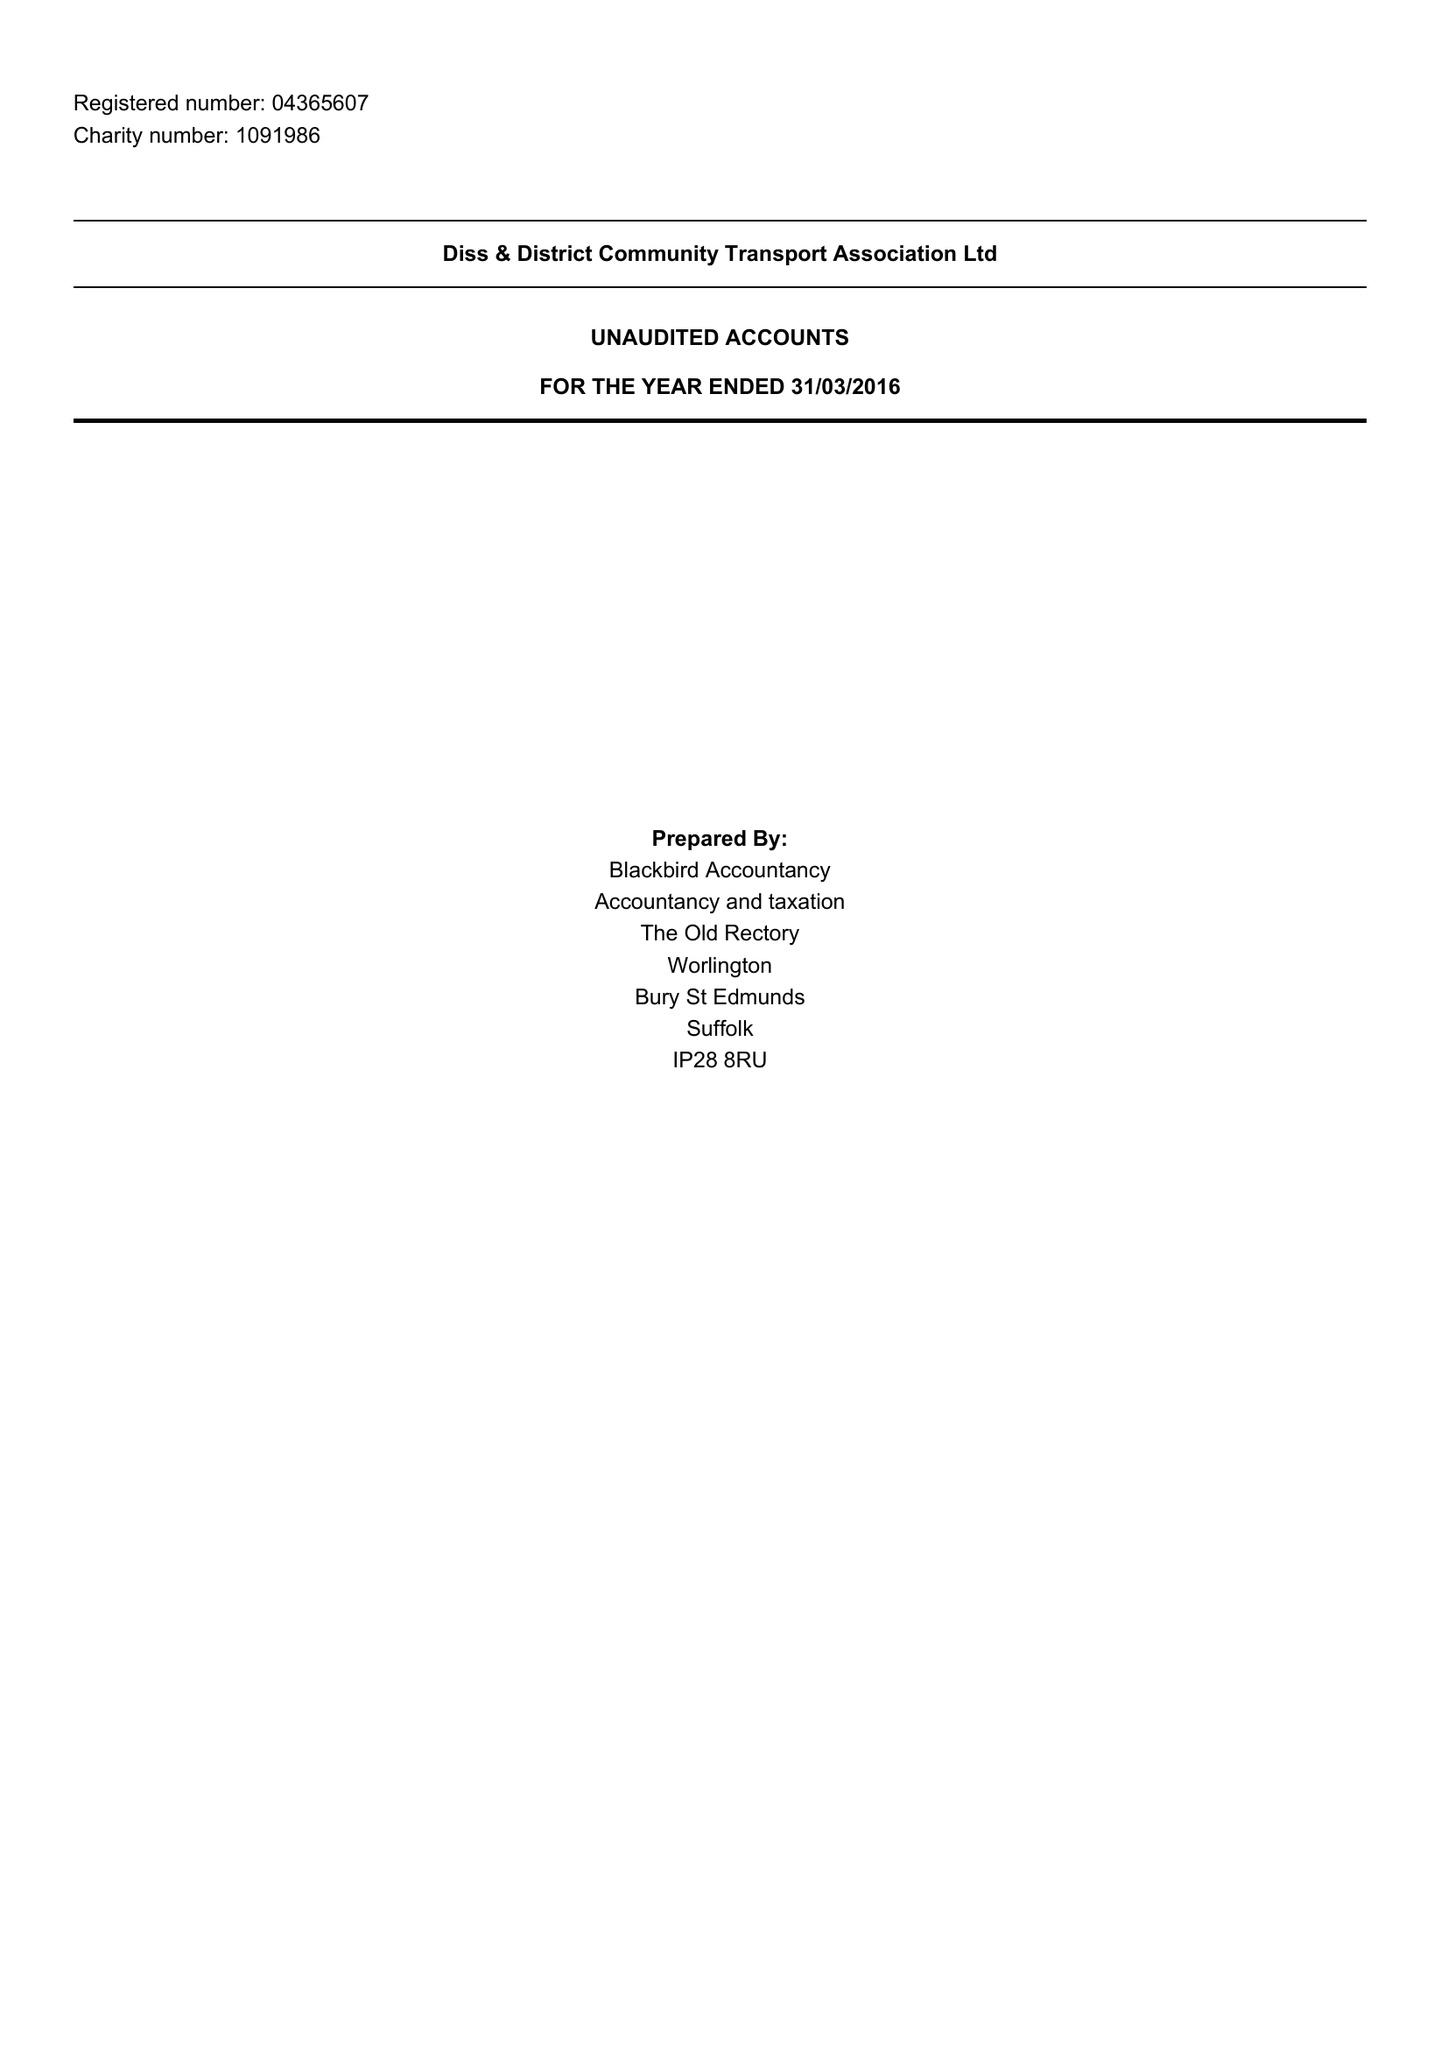What is the value for the charity_name?
Answer the question using a single word or phrase. Diss and District Community Transport Association Ltd. 